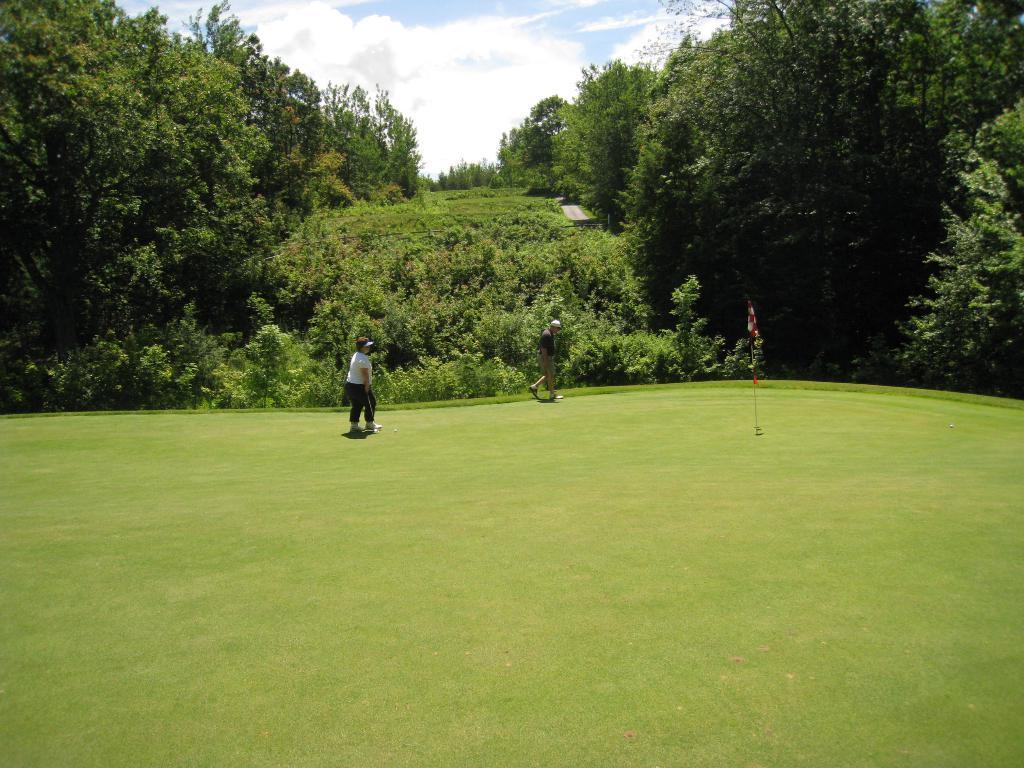What can be seen in the image that represents a symbol or country? There is a flag in the image. How many people are present in the image? There are two people in the image. Where are the people located in the image? The people are on the grass. What can be seen in the background of the image? There are trees and the sky visible in the background of the image. What is the condition of the sky in the image? Clouds are present in the sky. What type of flower can be seen growing near the people in the image? There is no flower present in the image; the people are on the grass, and the background features trees and the sky. Can you tell me how many deer are visible in the image? There are no deer present in the image; it features a flag, two people, grass, trees, and the sky. 